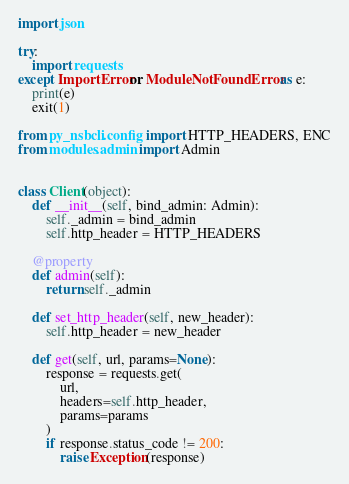<code> <loc_0><loc_0><loc_500><loc_500><_Python_>import json

try:
    import requests
except ImportError or ModuleNotFoundError as e:
    print(e)
    exit(1)

from py_nsbcli.config import HTTP_HEADERS, ENC
from modules.admin import Admin


class Client(object):
    def __init__(self, bind_admin: Admin):
        self._admin = bind_admin
        self.http_header = HTTP_HEADERS

    @property
    def admin(self):
        return self._admin

    def set_http_header(self, new_header):
        self.http_header = new_header

    def get(self, url, params=None):
        response = requests.get(
            url,
            headers=self.http_header,
            params=params
        )
        if response.status_code != 200:
            raise Exception(response)</code> 